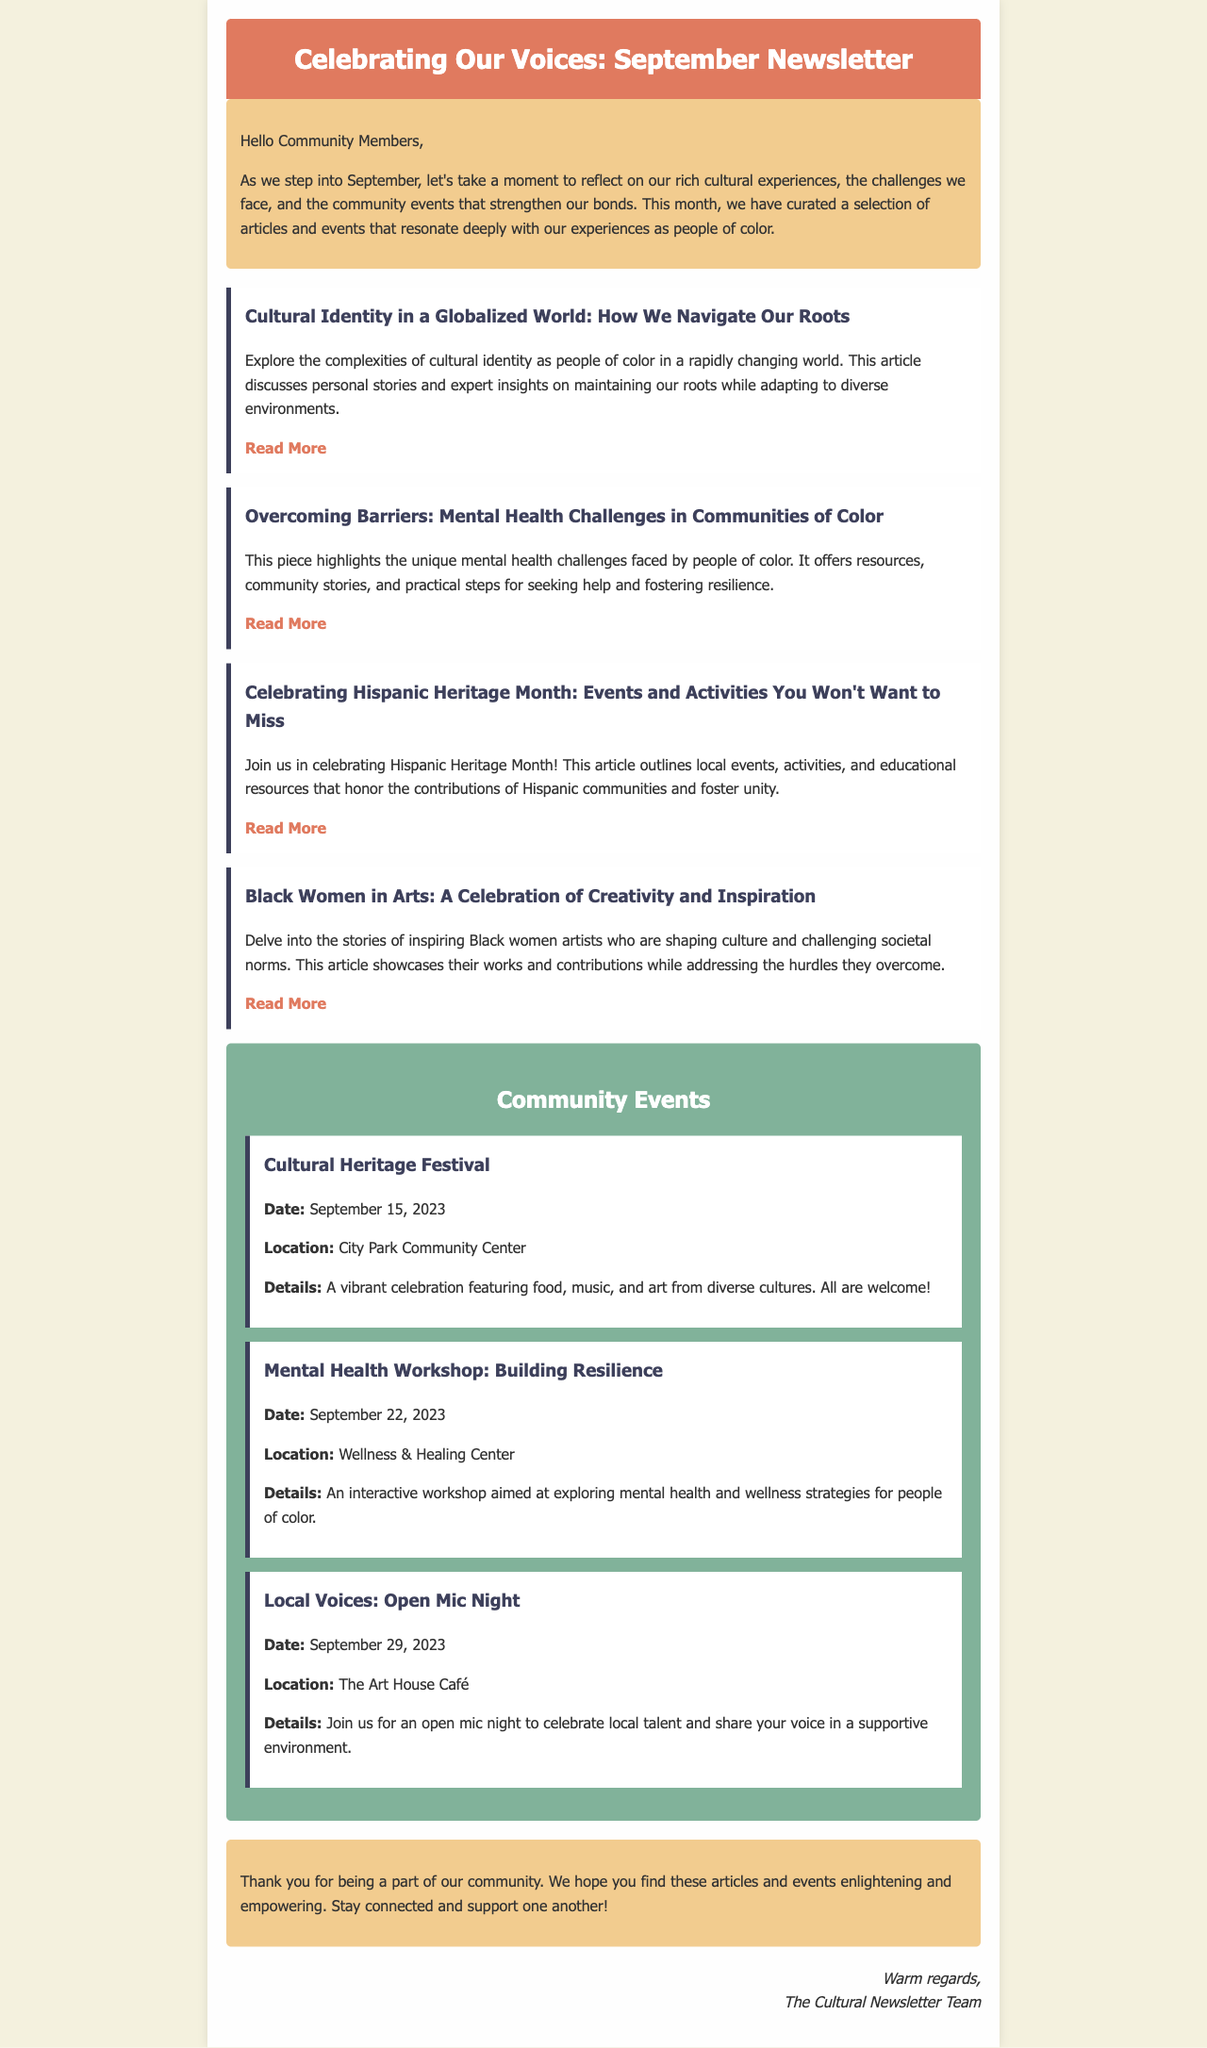what is the title of the newsletter? The title is prominently displayed at the top of the newsletter.
Answer: Celebrating Our Voices: September Newsletter how many articles are featured in this newsletter? The newsletter lists a total of four articles in the articles section.
Answer: 4 what is the date of the Cultural Heritage Festival? The date is mentioned clearly in the community events section.
Answer: September 15, 2023 who is the target audience of the articles in the newsletter? The introduction and content of the newsletter suggest it is aimed at a specific demographic.
Answer: People of color what type of events are included in the community section? The community section highlights various types of gatherings and activities that promote culture and mental health.
Answer: Cultural and mental health events what is the main theme of the article titled "Overcoming Barriers"? This article focuses on a specific topic that affects individuals in certain communities.
Answer: Mental health challenges where will the Mental Health Workshop take place? The location of the workshop is provided in the events section.
Answer: Wellness & Healing Center who is signed off as the newsletter team? The closure of the newsletter includes a signature that identifies the team responsible.
Answer: The Cultural Newsletter Team 